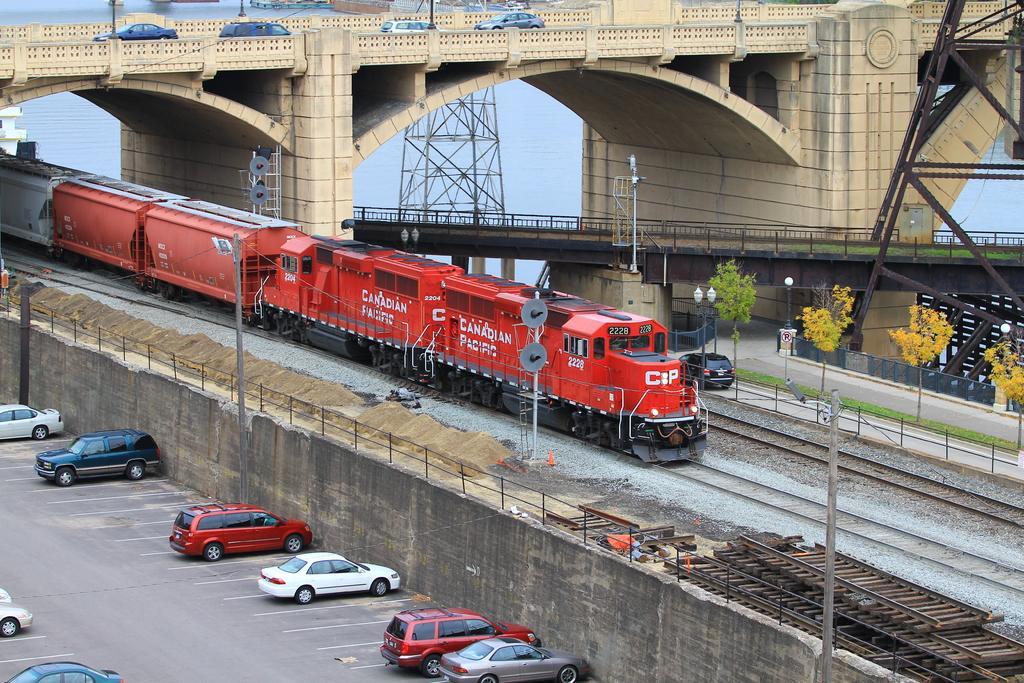In one or two sentences, can you explain what this image depicts? On the left there are cars parked in the parking area. In the center of the pictures there are railway tracks, trees, poles, train, stones and other objects. At the top there is a bridge, on the bridge there are cars moving. In the center of the background there are bridge, tower and a water body. On the right there is iron tower. 